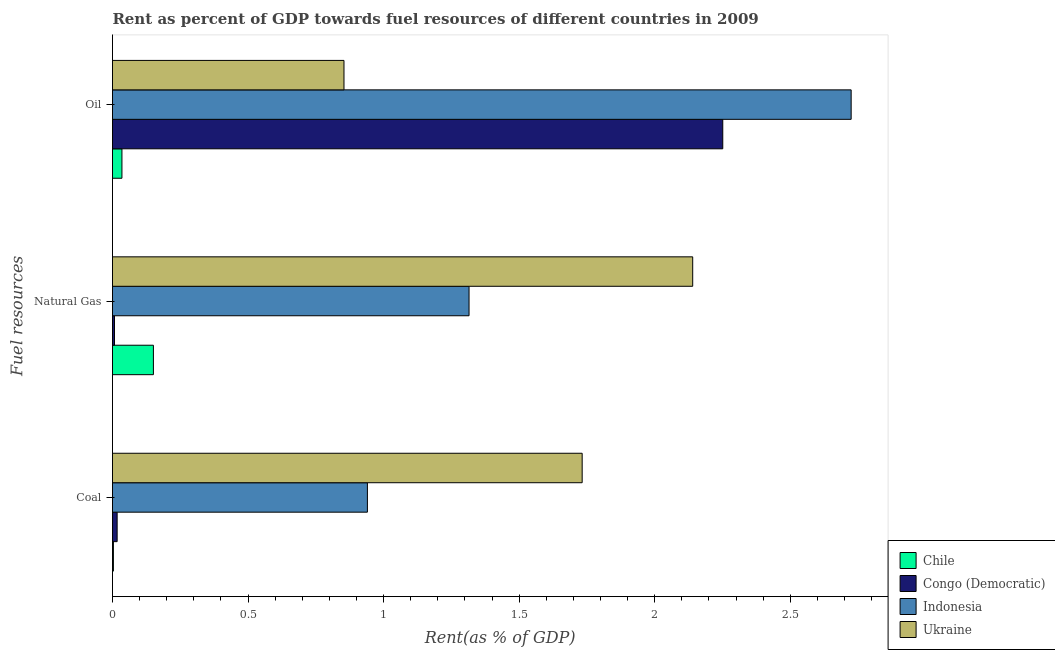How many different coloured bars are there?
Your answer should be compact. 4. How many groups of bars are there?
Provide a short and direct response. 3. Are the number of bars per tick equal to the number of legend labels?
Ensure brevity in your answer.  Yes. How many bars are there on the 1st tick from the bottom?
Your answer should be compact. 4. What is the label of the 3rd group of bars from the top?
Offer a very short reply. Coal. What is the rent towards coal in Indonesia?
Give a very brief answer. 0.94. Across all countries, what is the maximum rent towards natural gas?
Make the answer very short. 2.14. Across all countries, what is the minimum rent towards natural gas?
Your response must be concise. 0.01. In which country was the rent towards oil maximum?
Offer a terse response. Indonesia. What is the total rent towards oil in the graph?
Offer a terse response. 5.86. What is the difference between the rent towards coal in Indonesia and that in Congo (Democratic)?
Your answer should be compact. 0.92. What is the difference between the rent towards oil in Congo (Democratic) and the rent towards coal in Chile?
Make the answer very short. 2.25. What is the average rent towards oil per country?
Offer a very short reply. 1.47. What is the difference between the rent towards coal and rent towards oil in Indonesia?
Ensure brevity in your answer.  -1.78. In how many countries, is the rent towards oil greater than 2.4 %?
Give a very brief answer. 1. What is the ratio of the rent towards oil in Indonesia to that in Ukraine?
Your response must be concise. 3.19. Is the rent towards coal in Indonesia less than that in Congo (Democratic)?
Your response must be concise. No. What is the difference between the highest and the second highest rent towards coal?
Ensure brevity in your answer.  0.79. What is the difference between the highest and the lowest rent towards oil?
Give a very brief answer. 2.69. What does the 4th bar from the top in Coal represents?
Give a very brief answer. Chile. Are all the bars in the graph horizontal?
Offer a very short reply. Yes. How many countries are there in the graph?
Your answer should be very brief. 4. What is the difference between two consecutive major ticks on the X-axis?
Offer a terse response. 0.5. Does the graph contain any zero values?
Provide a short and direct response. No. Does the graph contain grids?
Keep it short and to the point. No. Where does the legend appear in the graph?
Give a very brief answer. Bottom right. What is the title of the graph?
Ensure brevity in your answer.  Rent as percent of GDP towards fuel resources of different countries in 2009. What is the label or title of the X-axis?
Provide a succinct answer. Rent(as % of GDP). What is the label or title of the Y-axis?
Your answer should be compact. Fuel resources. What is the Rent(as % of GDP) of Chile in Coal?
Offer a very short reply. 0. What is the Rent(as % of GDP) in Congo (Democratic) in Coal?
Give a very brief answer. 0.02. What is the Rent(as % of GDP) in Indonesia in Coal?
Your response must be concise. 0.94. What is the Rent(as % of GDP) of Ukraine in Coal?
Offer a very short reply. 1.73. What is the Rent(as % of GDP) in Chile in Natural Gas?
Provide a short and direct response. 0.15. What is the Rent(as % of GDP) of Congo (Democratic) in Natural Gas?
Offer a terse response. 0.01. What is the Rent(as % of GDP) in Indonesia in Natural Gas?
Provide a succinct answer. 1.32. What is the Rent(as % of GDP) of Ukraine in Natural Gas?
Offer a very short reply. 2.14. What is the Rent(as % of GDP) in Chile in Oil?
Provide a succinct answer. 0.03. What is the Rent(as % of GDP) in Congo (Democratic) in Oil?
Make the answer very short. 2.25. What is the Rent(as % of GDP) in Indonesia in Oil?
Keep it short and to the point. 2.72. What is the Rent(as % of GDP) in Ukraine in Oil?
Your response must be concise. 0.85. Across all Fuel resources, what is the maximum Rent(as % of GDP) in Chile?
Provide a succinct answer. 0.15. Across all Fuel resources, what is the maximum Rent(as % of GDP) in Congo (Democratic)?
Provide a succinct answer. 2.25. Across all Fuel resources, what is the maximum Rent(as % of GDP) of Indonesia?
Your answer should be very brief. 2.72. Across all Fuel resources, what is the maximum Rent(as % of GDP) in Ukraine?
Provide a succinct answer. 2.14. Across all Fuel resources, what is the minimum Rent(as % of GDP) in Chile?
Make the answer very short. 0. Across all Fuel resources, what is the minimum Rent(as % of GDP) of Congo (Democratic)?
Ensure brevity in your answer.  0.01. Across all Fuel resources, what is the minimum Rent(as % of GDP) of Indonesia?
Keep it short and to the point. 0.94. Across all Fuel resources, what is the minimum Rent(as % of GDP) in Ukraine?
Ensure brevity in your answer.  0.85. What is the total Rent(as % of GDP) in Chile in the graph?
Your answer should be very brief. 0.19. What is the total Rent(as % of GDP) in Congo (Democratic) in the graph?
Your response must be concise. 2.28. What is the total Rent(as % of GDP) of Indonesia in the graph?
Provide a short and direct response. 4.98. What is the total Rent(as % of GDP) of Ukraine in the graph?
Provide a short and direct response. 4.73. What is the difference between the Rent(as % of GDP) of Chile in Coal and that in Natural Gas?
Offer a very short reply. -0.15. What is the difference between the Rent(as % of GDP) of Congo (Democratic) in Coal and that in Natural Gas?
Offer a terse response. 0.01. What is the difference between the Rent(as % of GDP) in Indonesia in Coal and that in Natural Gas?
Your response must be concise. -0.37. What is the difference between the Rent(as % of GDP) of Ukraine in Coal and that in Natural Gas?
Your answer should be compact. -0.41. What is the difference between the Rent(as % of GDP) in Chile in Coal and that in Oil?
Ensure brevity in your answer.  -0.03. What is the difference between the Rent(as % of GDP) of Congo (Democratic) in Coal and that in Oil?
Provide a succinct answer. -2.23. What is the difference between the Rent(as % of GDP) in Indonesia in Coal and that in Oil?
Give a very brief answer. -1.78. What is the difference between the Rent(as % of GDP) in Ukraine in Coal and that in Oil?
Your answer should be compact. 0.88. What is the difference between the Rent(as % of GDP) of Chile in Natural Gas and that in Oil?
Ensure brevity in your answer.  0.12. What is the difference between the Rent(as % of GDP) in Congo (Democratic) in Natural Gas and that in Oil?
Your response must be concise. -2.24. What is the difference between the Rent(as % of GDP) in Indonesia in Natural Gas and that in Oil?
Ensure brevity in your answer.  -1.41. What is the difference between the Rent(as % of GDP) of Ukraine in Natural Gas and that in Oil?
Your response must be concise. 1.29. What is the difference between the Rent(as % of GDP) of Chile in Coal and the Rent(as % of GDP) of Congo (Democratic) in Natural Gas?
Provide a succinct answer. -0. What is the difference between the Rent(as % of GDP) in Chile in Coal and the Rent(as % of GDP) in Indonesia in Natural Gas?
Make the answer very short. -1.31. What is the difference between the Rent(as % of GDP) in Chile in Coal and the Rent(as % of GDP) in Ukraine in Natural Gas?
Offer a terse response. -2.14. What is the difference between the Rent(as % of GDP) in Congo (Democratic) in Coal and the Rent(as % of GDP) in Indonesia in Natural Gas?
Your answer should be compact. -1.3. What is the difference between the Rent(as % of GDP) in Congo (Democratic) in Coal and the Rent(as % of GDP) in Ukraine in Natural Gas?
Offer a very short reply. -2.12. What is the difference between the Rent(as % of GDP) in Indonesia in Coal and the Rent(as % of GDP) in Ukraine in Natural Gas?
Provide a short and direct response. -1.2. What is the difference between the Rent(as % of GDP) in Chile in Coal and the Rent(as % of GDP) in Congo (Democratic) in Oil?
Offer a very short reply. -2.25. What is the difference between the Rent(as % of GDP) of Chile in Coal and the Rent(as % of GDP) of Indonesia in Oil?
Your answer should be compact. -2.72. What is the difference between the Rent(as % of GDP) of Chile in Coal and the Rent(as % of GDP) of Ukraine in Oil?
Provide a succinct answer. -0.85. What is the difference between the Rent(as % of GDP) in Congo (Democratic) in Coal and the Rent(as % of GDP) in Indonesia in Oil?
Give a very brief answer. -2.71. What is the difference between the Rent(as % of GDP) in Congo (Democratic) in Coal and the Rent(as % of GDP) in Ukraine in Oil?
Give a very brief answer. -0.84. What is the difference between the Rent(as % of GDP) of Indonesia in Coal and the Rent(as % of GDP) of Ukraine in Oil?
Ensure brevity in your answer.  0.09. What is the difference between the Rent(as % of GDP) of Chile in Natural Gas and the Rent(as % of GDP) of Congo (Democratic) in Oil?
Offer a terse response. -2.1. What is the difference between the Rent(as % of GDP) in Chile in Natural Gas and the Rent(as % of GDP) in Indonesia in Oil?
Ensure brevity in your answer.  -2.57. What is the difference between the Rent(as % of GDP) in Chile in Natural Gas and the Rent(as % of GDP) in Ukraine in Oil?
Ensure brevity in your answer.  -0.7. What is the difference between the Rent(as % of GDP) in Congo (Democratic) in Natural Gas and the Rent(as % of GDP) in Indonesia in Oil?
Make the answer very short. -2.72. What is the difference between the Rent(as % of GDP) in Congo (Democratic) in Natural Gas and the Rent(as % of GDP) in Ukraine in Oil?
Give a very brief answer. -0.85. What is the difference between the Rent(as % of GDP) in Indonesia in Natural Gas and the Rent(as % of GDP) in Ukraine in Oil?
Make the answer very short. 0.46. What is the average Rent(as % of GDP) of Chile per Fuel resources?
Offer a very short reply. 0.06. What is the average Rent(as % of GDP) of Congo (Democratic) per Fuel resources?
Your answer should be compact. 0.76. What is the average Rent(as % of GDP) in Indonesia per Fuel resources?
Provide a short and direct response. 1.66. What is the average Rent(as % of GDP) in Ukraine per Fuel resources?
Provide a short and direct response. 1.58. What is the difference between the Rent(as % of GDP) of Chile and Rent(as % of GDP) of Congo (Democratic) in Coal?
Your answer should be very brief. -0.01. What is the difference between the Rent(as % of GDP) of Chile and Rent(as % of GDP) of Indonesia in Coal?
Make the answer very short. -0.94. What is the difference between the Rent(as % of GDP) in Chile and Rent(as % of GDP) in Ukraine in Coal?
Give a very brief answer. -1.73. What is the difference between the Rent(as % of GDP) in Congo (Democratic) and Rent(as % of GDP) in Indonesia in Coal?
Your answer should be very brief. -0.92. What is the difference between the Rent(as % of GDP) of Congo (Democratic) and Rent(as % of GDP) of Ukraine in Coal?
Provide a succinct answer. -1.72. What is the difference between the Rent(as % of GDP) in Indonesia and Rent(as % of GDP) in Ukraine in Coal?
Your answer should be compact. -0.79. What is the difference between the Rent(as % of GDP) of Chile and Rent(as % of GDP) of Congo (Democratic) in Natural Gas?
Provide a succinct answer. 0.14. What is the difference between the Rent(as % of GDP) of Chile and Rent(as % of GDP) of Indonesia in Natural Gas?
Give a very brief answer. -1.16. What is the difference between the Rent(as % of GDP) of Chile and Rent(as % of GDP) of Ukraine in Natural Gas?
Ensure brevity in your answer.  -1.99. What is the difference between the Rent(as % of GDP) in Congo (Democratic) and Rent(as % of GDP) in Indonesia in Natural Gas?
Provide a succinct answer. -1.31. What is the difference between the Rent(as % of GDP) in Congo (Democratic) and Rent(as % of GDP) in Ukraine in Natural Gas?
Make the answer very short. -2.13. What is the difference between the Rent(as % of GDP) of Indonesia and Rent(as % of GDP) of Ukraine in Natural Gas?
Offer a terse response. -0.82. What is the difference between the Rent(as % of GDP) of Chile and Rent(as % of GDP) of Congo (Democratic) in Oil?
Ensure brevity in your answer.  -2.22. What is the difference between the Rent(as % of GDP) in Chile and Rent(as % of GDP) in Indonesia in Oil?
Provide a succinct answer. -2.69. What is the difference between the Rent(as % of GDP) in Chile and Rent(as % of GDP) in Ukraine in Oil?
Your response must be concise. -0.82. What is the difference between the Rent(as % of GDP) in Congo (Democratic) and Rent(as % of GDP) in Indonesia in Oil?
Provide a short and direct response. -0.47. What is the difference between the Rent(as % of GDP) of Congo (Democratic) and Rent(as % of GDP) of Ukraine in Oil?
Offer a terse response. 1.4. What is the difference between the Rent(as % of GDP) of Indonesia and Rent(as % of GDP) of Ukraine in Oil?
Provide a succinct answer. 1.87. What is the ratio of the Rent(as % of GDP) of Chile in Coal to that in Natural Gas?
Ensure brevity in your answer.  0.02. What is the ratio of the Rent(as % of GDP) in Congo (Democratic) in Coal to that in Natural Gas?
Give a very brief answer. 2.32. What is the ratio of the Rent(as % of GDP) of Indonesia in Coal to that in Natural Gas?
Offer a terse response. 0.71. What is the ratio of the Rent(as % of GDP) of Ukraine in Coal to that in Natural Gas?
Provide a short and direct response. 0.81. What is the ratio of the Rent(as % of GDP) of Chile in Coal to that in Oil?
Keep it short and to the point. 0.1. What is the ratio of the Rent(as % of GDP) of Congo (Democratic) in Coal to that in Oil?
Offer a very short reply. 0.01. What is the ratio of the Rent(as % of GDP) of Indonesia in Coal to that in Oil?
Your answer should be compact. 0.35. What is the ratio of the Rent(as % of GDP) of Ukraine in Coal to that in Oil?
Provide a succinct answer. 2.03. What is the ratio of the Rent(as % of GDP) in Chile in Natural Gas to that in Oil?
Keep it short and to the point. 4.34. What is the ratio of the Rent(as % of GDP) in Congo (Democratic) in Natural Gas to that in Oil?
Your response must be concise. 0. What is the ratio of the Rent(as % of GDP) in Indonesia in Natural Gas to that in Oil?
Provide a succinct answer. 0.48. What is the ratio of the Rent(as % of GDP) in Ukraine in Natural Gas to that in Oil?
Keep it short and to the point. 2.51. What is the difference between the highest and the second highest Rent(as % of GDP) of Chile?
Ensure brevity in your answer.  0.12. What is the difference between the highest and the second highest Rent(as % of GDP) in Congo (Democratic)?
Ensure brevity in your answer.  2.23. What is the difference between the highest and the second highest Rent(as % of GDP) of Indonesia?
Keep it short and to the point. 1.41. What is the difference between the highest and the second highest Rent(as % of GDP) of Ukraine?
Provide a short and direct response. 0.41. What is the difference between the highest and the lowest Rent(as % of GDP) in Chile?
Your response must be concise. 0.15. What is the difference between the highest and the lowest Rent(as % of GDP) of Congo (Democratic)?
Offer a very short reply. 2.24. What is the difference between the highest and the lowest Rent(as % of GDP) of Indonesia?
Ensure brevity in your answer.  1.78. What is the difference between the highest and the lowest Rent(as % of GDP) in Ukraine?
Give a very brief answer. 1.29. 